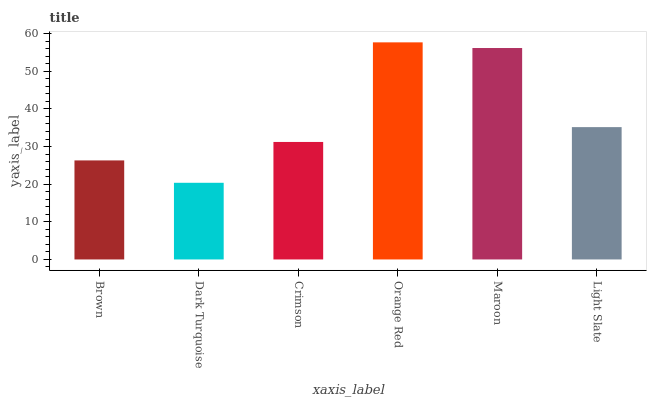Is Crimson the minimum?
Answer yes or no. No. Is Crimson the maximum?
Answer yes or no. No. Is Crimson greater than Dark Turquoise?
Answer yes or no. Yes. Is Dark Turquoise less than Crimson?
Answer yes or no. Yes. Is Dark Turquoise greater than Crimson?
Answer yes or no. No. Is Crimson less than Dark Turquoise?
Answer yes or no. No. Is Light Slate the high median?
Answer yes or no. Yes. Is Crimson the low median?
Answer yes or no. Yes. Is Crimson the high median?
Answer yes or no. No. Is Orange Red the low median?
Answer yes or no. No. 